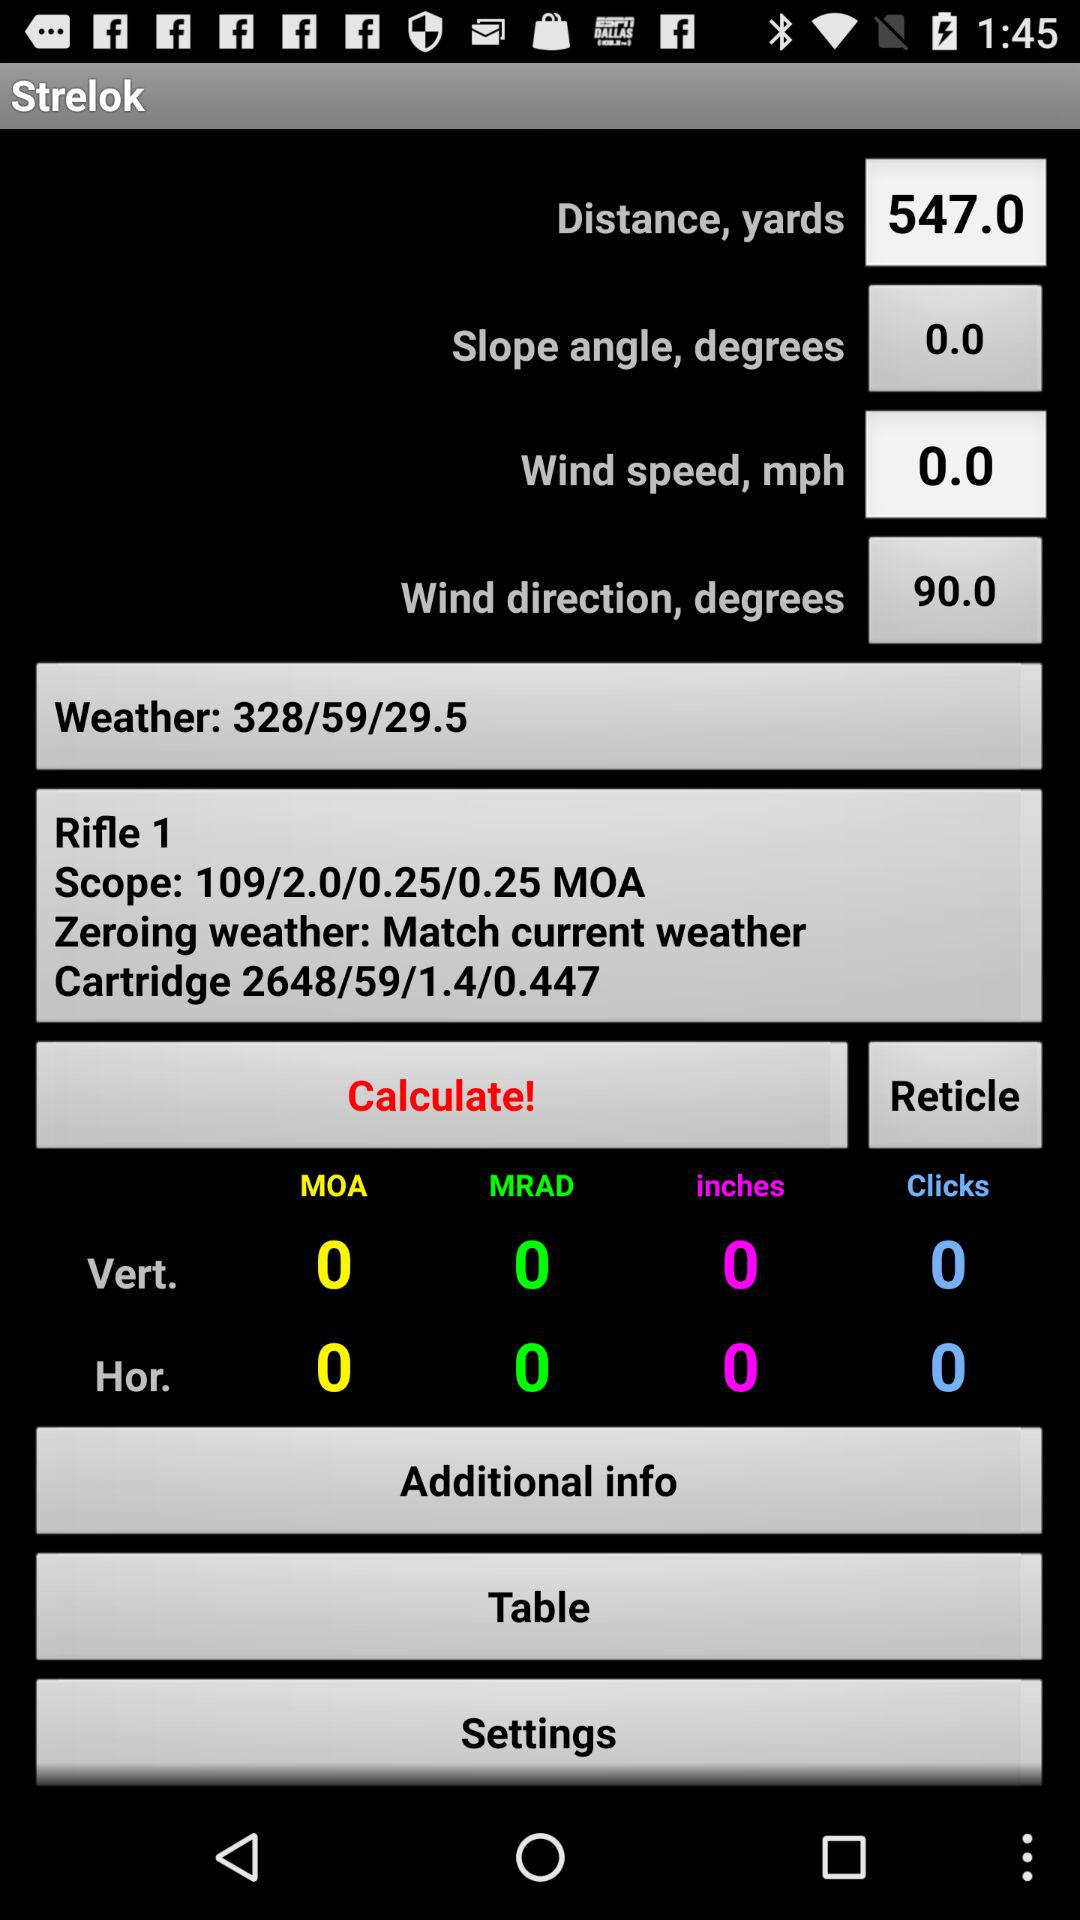What is the wind direction in degrees? The wind direction in degrees is 90.0. 